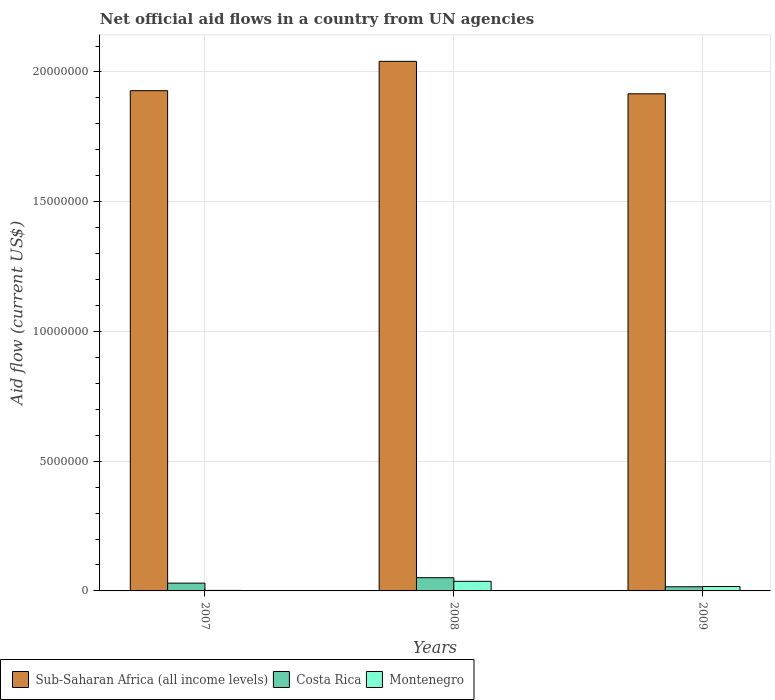How many bars are there on the 1st tick from the right?
Provide a succinct answer. 3. What is the label of the 2nd group of bars from the left?
Give a very brief answer. 2008. In how many cases, is the number of bars for a given year not equal to the number of legend labels?
Make the answer very short. 0. What is the net official aid flow in Costa Rica in 2009?
Make the answer very short. 1.60e+05. Across all years, what is the maximum net official aid flow in Costa Rica?
Provide a succinct answer. 5.10e+05. Across all years, what is the minimum net official aid flow in Sub-Saharan Africa (all income levels)?
Provide a succinct answer. 1.92e+07. What is the total net official aid flow in Montenegro in the graph?
Offer a terse response. 5.60e+05. What is the difference between the net official aid flow in Sub-Saharan Africa (all income levels) in 2008 and that in 2009?
Offer a very short reply. 1.25e+06. What is the difference between the net official aid flow in Costa Rica in 2007 and the net official aid flow in Sub-Saharan Africa (all income levels) in 2009?
Your answer should be very brief. -1.89e+07. What is the average net official aid flow in Costa Rica per year?
Keep it short and to the point. 3.23e+05. What is the ratio of the net official aid flow in Montenegro in 2008 to that in 2009?
Give a very brief answer. 2.18. Is the net official aid flow in Costa Rica in 2007 less than that in 2008?
Provide a succinct answer. Yes. Is the difference between the net official aid flow in Montenegro in 2008 and 2009 greater than the difference between the net official aid flow in Costa Rica in 2008 and 2009?
Offer a very short reply. No. What is the difference between the highest and the lowest net official aid flow in Sub-Saharan Africa (all income levels)?
Your answer should be compact. 1.25e+06. Is the sum of the net official aid flow in Sub-Saharan Africa (all income levels) in 2007 and 2008 greater than the maximum net official aid flow in Montenegro across all years?
Your answer should be very brief. Yes. What does the 1st bar from the right in 2009 represents?
Provide a short and direct response. Montenegro. How many bars are there?
Provide a short and direct response. 9. How many years are there in the graph?
Your response must be concise. 3. Are the values on the major ticks of Y-axis written in scientific E-notation?
Your response must be concise. No. Where does the legend appear in the graph?
Provide a succinct answer. Bottom left. How are the legend labels stacked?
Offer a terse response. Horizontal. What is the title of the graph?
Give a very brief answer. Net official aid flows in a country from UN agencies. What is the label or title of the X-axis?
Give a very brief answer. Years. What is the label or title of the Y-axis?
Ensure brevity in your answer.  Aid flow (current US$). What is the Aid flow (current US$) of Sub-Saharan Africa (all income levels) in 2007?
Your answer should be compact. 1.93e+07. What is the Aid flow (current US$) in Costa Rica in 2007?
Offer a terse response. 3.00e+05. What is the Aid flow (current US$) in Montenegro in 2007?
Your answer should be compact. 2.00e+04. What is the Aid flow (current US$) of Sub-Saharan Africa (all income levels) in 2008?
Make the answer very short. 2.04e+07. What is the Aid flow (current US$) of Costa Rica in 2008?
Provide a succinct answer. 5.10e+05. What is the Aid flow (current US$) of Montenegro in 2008?
Offer a very short reply. 3.70e+05. What is the Aid flow (current US$) of Sub-Saharan Africa (all income levels) in 2009?
Ensure brevity in your answer.  1.92e+07. What is the Aid flow (current US$) in Montenegro in 2009?
Provide a short and direct response. 1.70e+05. Across all years, what is the maximum Aid flow (current US$) of Sub-Saharan Africa (all income levels)?
Keep it short and to the point. 2.04e+07. Across all years, what is the maximum Aid flow (current US$) in Costa Rica?
Provide a short and direct response. 5.10e+05. Across all years, what is the minimum Aid flow (current US$) of Sub-Saharan Africa (all income levels)?
Your answer should be compact. 1.92e+07. Across all years, what is the minimum Aid flow (current US$) in Costa Rica?
Keep it short and to the point. 1.60e+05. Across all years, what is the minimum Aid flow (current US$) of Montenegro?
Ensure brevity in your answer.  2.00e+04. What is the total Aid flow (current US$) in Sub-Saharan Africa (all income levels) in the graph?
Provide a short and direct response. 5.88e+07. What is the total Aid flow (current US$) in Costa Rica in the graph?
Offer a terse response. 9.70e+05. What is the total Aid flow (current US$) in Montenegro in the graph?
Your response must be concise. 5.60e+05. What is the difference between the Aid flow (current US$) of Sub-Saharan Africa (all income levels) in 2007 and that in 2008?
Provide a succinct answer. -1.13e+06. What is the difference between the Aid flow (current US$) of Montenegro in 2007 and that in 2008?
Your response must be concise. -3.50e+05. What is the difference between the Aid flow (current US$) in Montenegro in 2007 and that in 2009?
Provide a short and direct response. -1.50e+05. What is the difference between the Aid flow (current US$) of Sub-Saharan Africa (all income levels) in 2008 and that in 2009?
Keep it short and to the point. 1.25e+06. What is the difference between the Aid flow (current US$) in Costa Rica in 2008 and that in 2009?
Your answer should be very brief. 3.50e+05. What is the difference between the Aid flow (current US$) in Montenegro in 2008 and that in 2009?
Give a very brief answer. 2.00e+05. What is the difference between the Aid flow (current US$) in Sub-Saharan Africa (all income levels) in 2007 and the Aid flow (current US$) in Costa Rica in 2008?
Offer a terse response. 1.88e+07. What is the difference between the Aid flow (current US$) in Sub-Saharan Africa (all income levels) in 2007 and the Aid flow (current US$) in Montenegro in 2008?
Keep it short and to the point. 1.89e+07. What is the difference between the Aid flow (current US$) in Sub-Saharan Africa (all income levels) in 2007 and the Aid flow (current US$) in Costa Rica in 2009?
Provide a short and direct response. 1.91e+07. What is the difference between the Aid flow (current US$) of Sub-Saharan Africa (all income levels) in 2007 and the Aid flow (current US$) of Montenegro in 2009?
Your response must be concise. 1.91e+07. What is the difference between the Aid flow (current US$) in Costa Rica in 2007 and the Aid flow (current US$) in Montenegro in 2009?
Make the answer very short. 1.30e+05. What is the difference between the Aid flow (current US$) in Sub-Saharan Africa (all income levels) in 2008 and the Aid flow (current US$) in Costa Rica in 2009?
Provide a short and direct response. 2.02e+07. What is the difference between the Aid flow (current US$) of Sub-Saharan Africa (all income levels) in 2008 and the Aid flow (current US$) of Montenegro in 2009?
Keep it short and to the point. 2.02e+07. What is the difference between the Aid flow (current US$) in Costa Rica in 2008 and the Aid flow (current US$) in Montenegro in 2009?
Make the answer very short. 3.40e+05. What is the average Aid flow (current US$) in Sub-Saharan Africa (all income levels) per year?
Provide a succinct answer. 1.96e+07. What is the average Aid flow (current US$) of Costa Rica per year?
Keep it short and to the point. 3.23e+05. What is the average Aid flow (current US$) of Montenegro per year?
Offer a very short reply. 1.87e+05. In the year 2007, what is the difference between the Aid flow (current US$) of Sub-Saharan Africa (all income levels) and Aid flow (current US$) of Costa Rica?
Offer a very short reply. 1.90e+07. In the year 2007, what is the difference between the Aid flow (current US$) of Sub-Saharan Africa (all income levels) and Aid flow (current US$) of Montenegro?
Give a very brief answer. 1.93e+07. In the year 2007, what is the difference between the Aid flow (current US$) in Costa Rica and Aid flow (current US$) in Montenegro?
Provide a short and direct response. 2.80e+05. In the year 2008, what is the difference between the Aid flow (current US$) in Sub-Saharan Africa (all income levels) and Aid flow (current US$) in Costa Rica?
Provide a succinct answer. 1.99e+07. In the year 2008, what is the difference between the Aid flow (current US$) of Sub-Saharan Africa (all income levels) and Aid flow (current US$) of Montenegro?
Provide a short and direct response. 2.00e+07. In the year 2008, what is the difference between the Aid flow (current US$) in Costa Rica and Aid flow (current US$) in Montenegro?
Keep it short and to the point. 1.40e+05. In the year 2009, what is the difference between the Aid flow (current US$) of Sub-Saharan Africa (all income levels) and Aid flow (current US$) of Costa Rica?
Keep it short and to the point. 1.90e+07. In the year 2009, what is the difference between the Aid flow (current US$) in Sub-Saharan Africa (all income levels) and Aid flow (current US$) in Montenegro?
Provide a succinct answer. 1.90e+07. In the year 2009, what is the difference between the Aid flow (current US$) in Costa Rica and Aid flow (current US$) in Montenegro?
Ensure brevity in your answer.  -10000. What is the ratio of the Aid flow (current US$) of Sub-Saharan Africa (all income levels) in 2007 to that in 2008?
Ensure brevity in your answer.  0.94. What is the ratio of the Aid flow (current US$) in Costa Rica in 2007 to that in 2008?
Make the answer very short. 0.59. What is the ratio of the Aid flow (current US$) of Montenegro in 2007 to that in 2008?
Provide a short and direct response. 0.05. What is the ratio of the Aid flow (current US$) in Costa Rica in 2007 to that in 2009?
Offer a terse response. 1.88. What is the ratio of the Aid flow (current US$) of Montenegro in 2007 to that in 2009?
Your answer should be very brief. 0.12. What is the ratio of the Aid flow (current US$) of Sub-Saharan Africa (all income levels) in 2008 to that in 2009?
Your answer should be very brief. 1.07. What is the ratio of the Aid flow (current US$) of Costa Rica in 2008 to that in 2009?
Your answer should be very brief. 3.19. What is the ratio of the Aid flow (current US$) in Montenegro in 2008 to that in 2009?
Offer a very short reply. 2.18. What is the difference between the highest and the second highest Aid flow (current US$) in Sub-Saharan Africa (all income levels)?
Give a very brief answer. 1.13e+06. What is the difference between the highest and the lowest Aid flow (current US$) of Sub-Saharan Africa (all income levels)?
Offer a terse response. 1.25e+06. What is the difference between the highest and the lowest Aid flow (current US$) in Costa Rica?
Keep it short and to the point. 3.50e+05. What is the difference between the highest and the lowest Aid flow (current US$) of Montenegro?
Provide a succinct answer. 3.50e+05. 